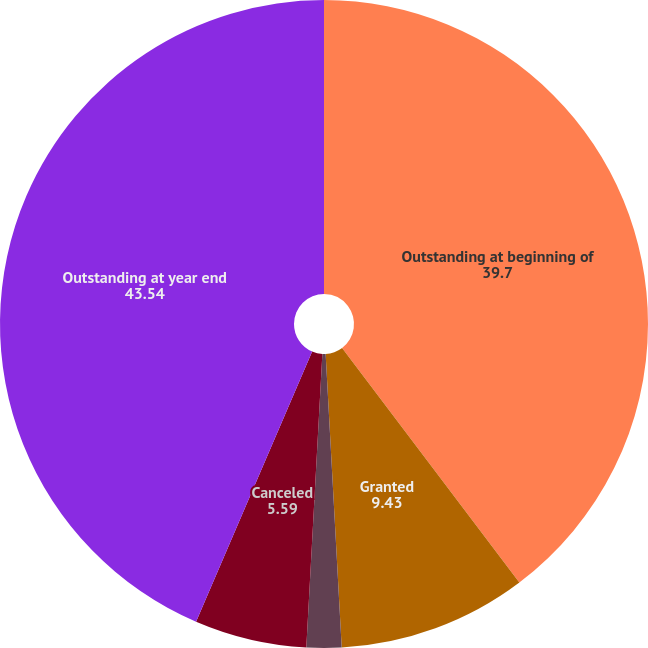Convert chart. <chart><loc_0><loc_0><loc_500><loc_500><pie_chart><fcel>Outstanding at beginning of<fcel>Granted<fcel>Exercised<fcel>Canceled<fcel>Outstanding at year end<nl><fcel>39.7%<fcel>9.43%<fcel>1.74%<fcel>5.59%<fcel>43.54%<nl></chart> 